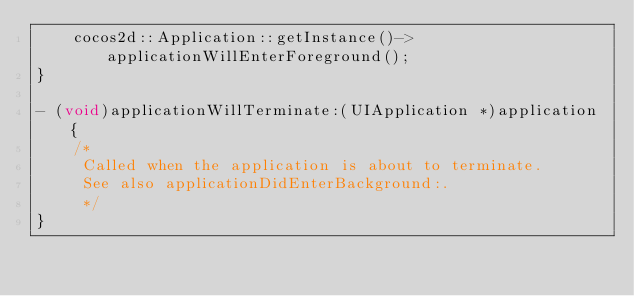Convert code to text. <code><loc_0><loc_0><loc_500><loc_500><_ObjectiveC_>    cocos2d::Application::getInstance()->applicationWillEnterForeground();
}

- (void)applicationWillTerminate:(UIApplication *)application {
    /*
     Called when the application is about to terminate.
     See also applicationDidEnterBackground:.
     */
}

</code> 